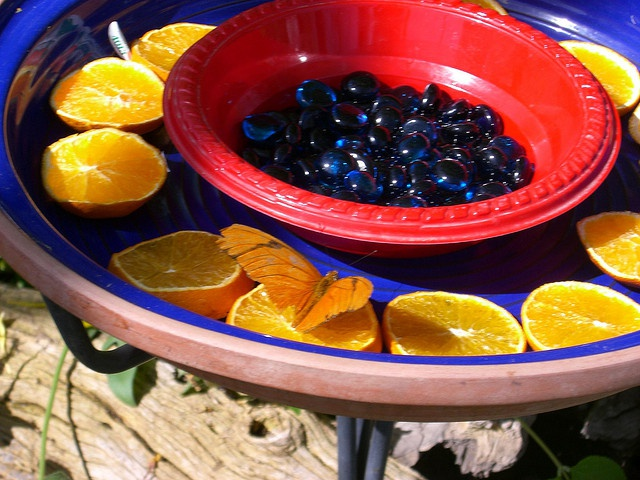Describe the objects in this image and their specific colors. I can see bowl in lightpink, black, red, maroon, and brown tones, orange in lightpink, orange, red, black, and gold tones, orange in lightpink, orange, brown, and gold tones, orange in lightpink, maroon, and brown tones, and orange in lightpink, gold, orange, and khaki tones in this image. 